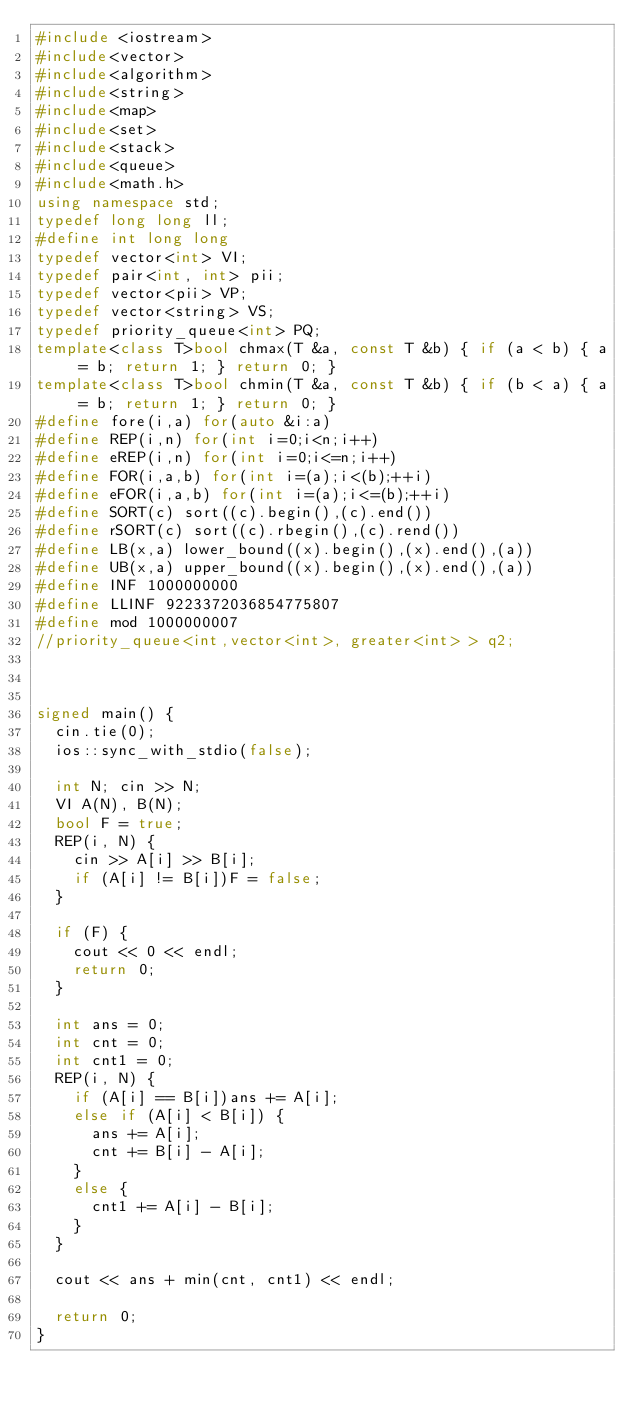Convert code to text. <code><loc_0><loc_0><loc_500><loc_500><_C++_>#include <iostream>
#include<vector>
#include<algorithm>
#include<string>
#include<map>
#include<set>
#include<stack>
#include<queue>
#include<math.h>
using namespace std;
typedef long long ll;
#define int long long
typedef vector<int> VI;
typedef pair<int, int> pii;
typedef vector<pii> VP;
typedef vector<string> VS;
typedef priority_queue<int> PQ;
template<class T>bool chmax(T &a, const T &b) { if (a < b) { a = b; return 1; } return 0; }
template<class T>bool chmin(T &a, const T &b) { if (b < a) { a = b; return 1; } return 0; }
#define fore(i,a) for(auto &i:a)
#define REP(i,n) for(int i=0;i<n;i++)
#define eREP(i,n) for(int i=0;i<=n;i++)
#define FOR(i,a,b) for(int i=(a);i<(b);++i)
#define eFOR(i,a,b) for(int i=(a);i<=(b);++i)
#define SORT(c) sort((c).begin(),(c).end())
#define rSORT(c) sort((c).rbegin(),(c).rend())
#define LB(x,a) lower_bound((x).begin(),(x).end(),(a))
#define UB(x,a) upper_bound((x).begin(),(x).end(),(a))
#define INF 1000000000
#define LLINF 9223372036854775807
#define mod 1000000007
//priority_queue<int,vector<int>, greater<int> > q2;



signed main() {
	cin.tie(0);
	ios::sync_with_stdio(false);

	int N; cin >> N;
	VI A(N), B(N);
	bool F = true;
	REP(i, N) {
		cin >> A[i] >> B[i];
		if (A[i] != B[i])F = false;
	}
	
	if (F) {
		cout << 0 << endl;
		return 0;
	}
	
	int ans = 0;
	int cnt = 0;
	int cnt1 = 0;
	REP(i, N) {
		if (A[i] == B[i])ans += A[i];
		else if (A[i] < B[i]) {
			ans += A[i];
			cnt += B[i] - A[i];
		}
		else {
			cnt1 += A[i] - B[i];
		}
	}

	cout << ans + min(cnt, cnt1) << endl;

	return 0;
}

</code> 